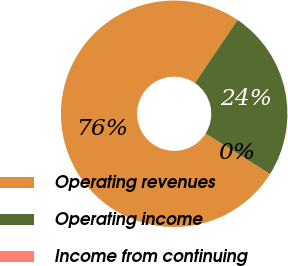Convert chart to OTSL. <chart><loc_0><loc_0><loc_500><loc_500><pie_chart><fcel>Operating revenues<fcel>Operating income<fcel>Income from continuing<nl><fcel>75.54%<fcel>24.46%<fcel>0.0%<nl></chart> 